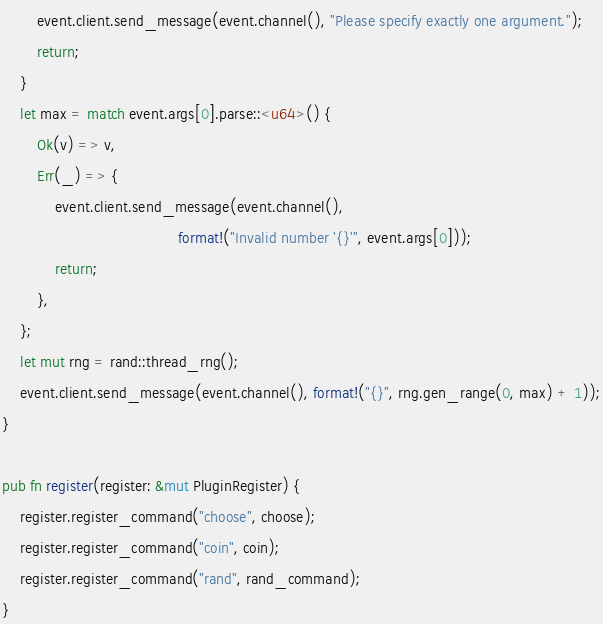Convert code to text. <code><loc_0><loc_0><loc_500><loc_500><_Rust_>        event.client.send_message(event.channel(), "Please specify exactly one argument.");
        return;
    }
    let max = match event.args[0].parse::<u64>() {
        Ok(v) => v,
        Err(_) => {
            event.client.send_message(event.channel(),
                                        format!("Invalid number '{}'", event.args[0]));
            return;
        },
    };
    let mut rng = rand::thread_rng();
    event.client.send_message(event.channel(), format!("{}", rng.gen_range(0, max) + 1));
}

pub fn register(register: &mut PluginRegister) {
    register.register_command("choose", choose);
    register.register_command("coin", coin);
    register.register_command("rand", rand_command);
}
</code> 